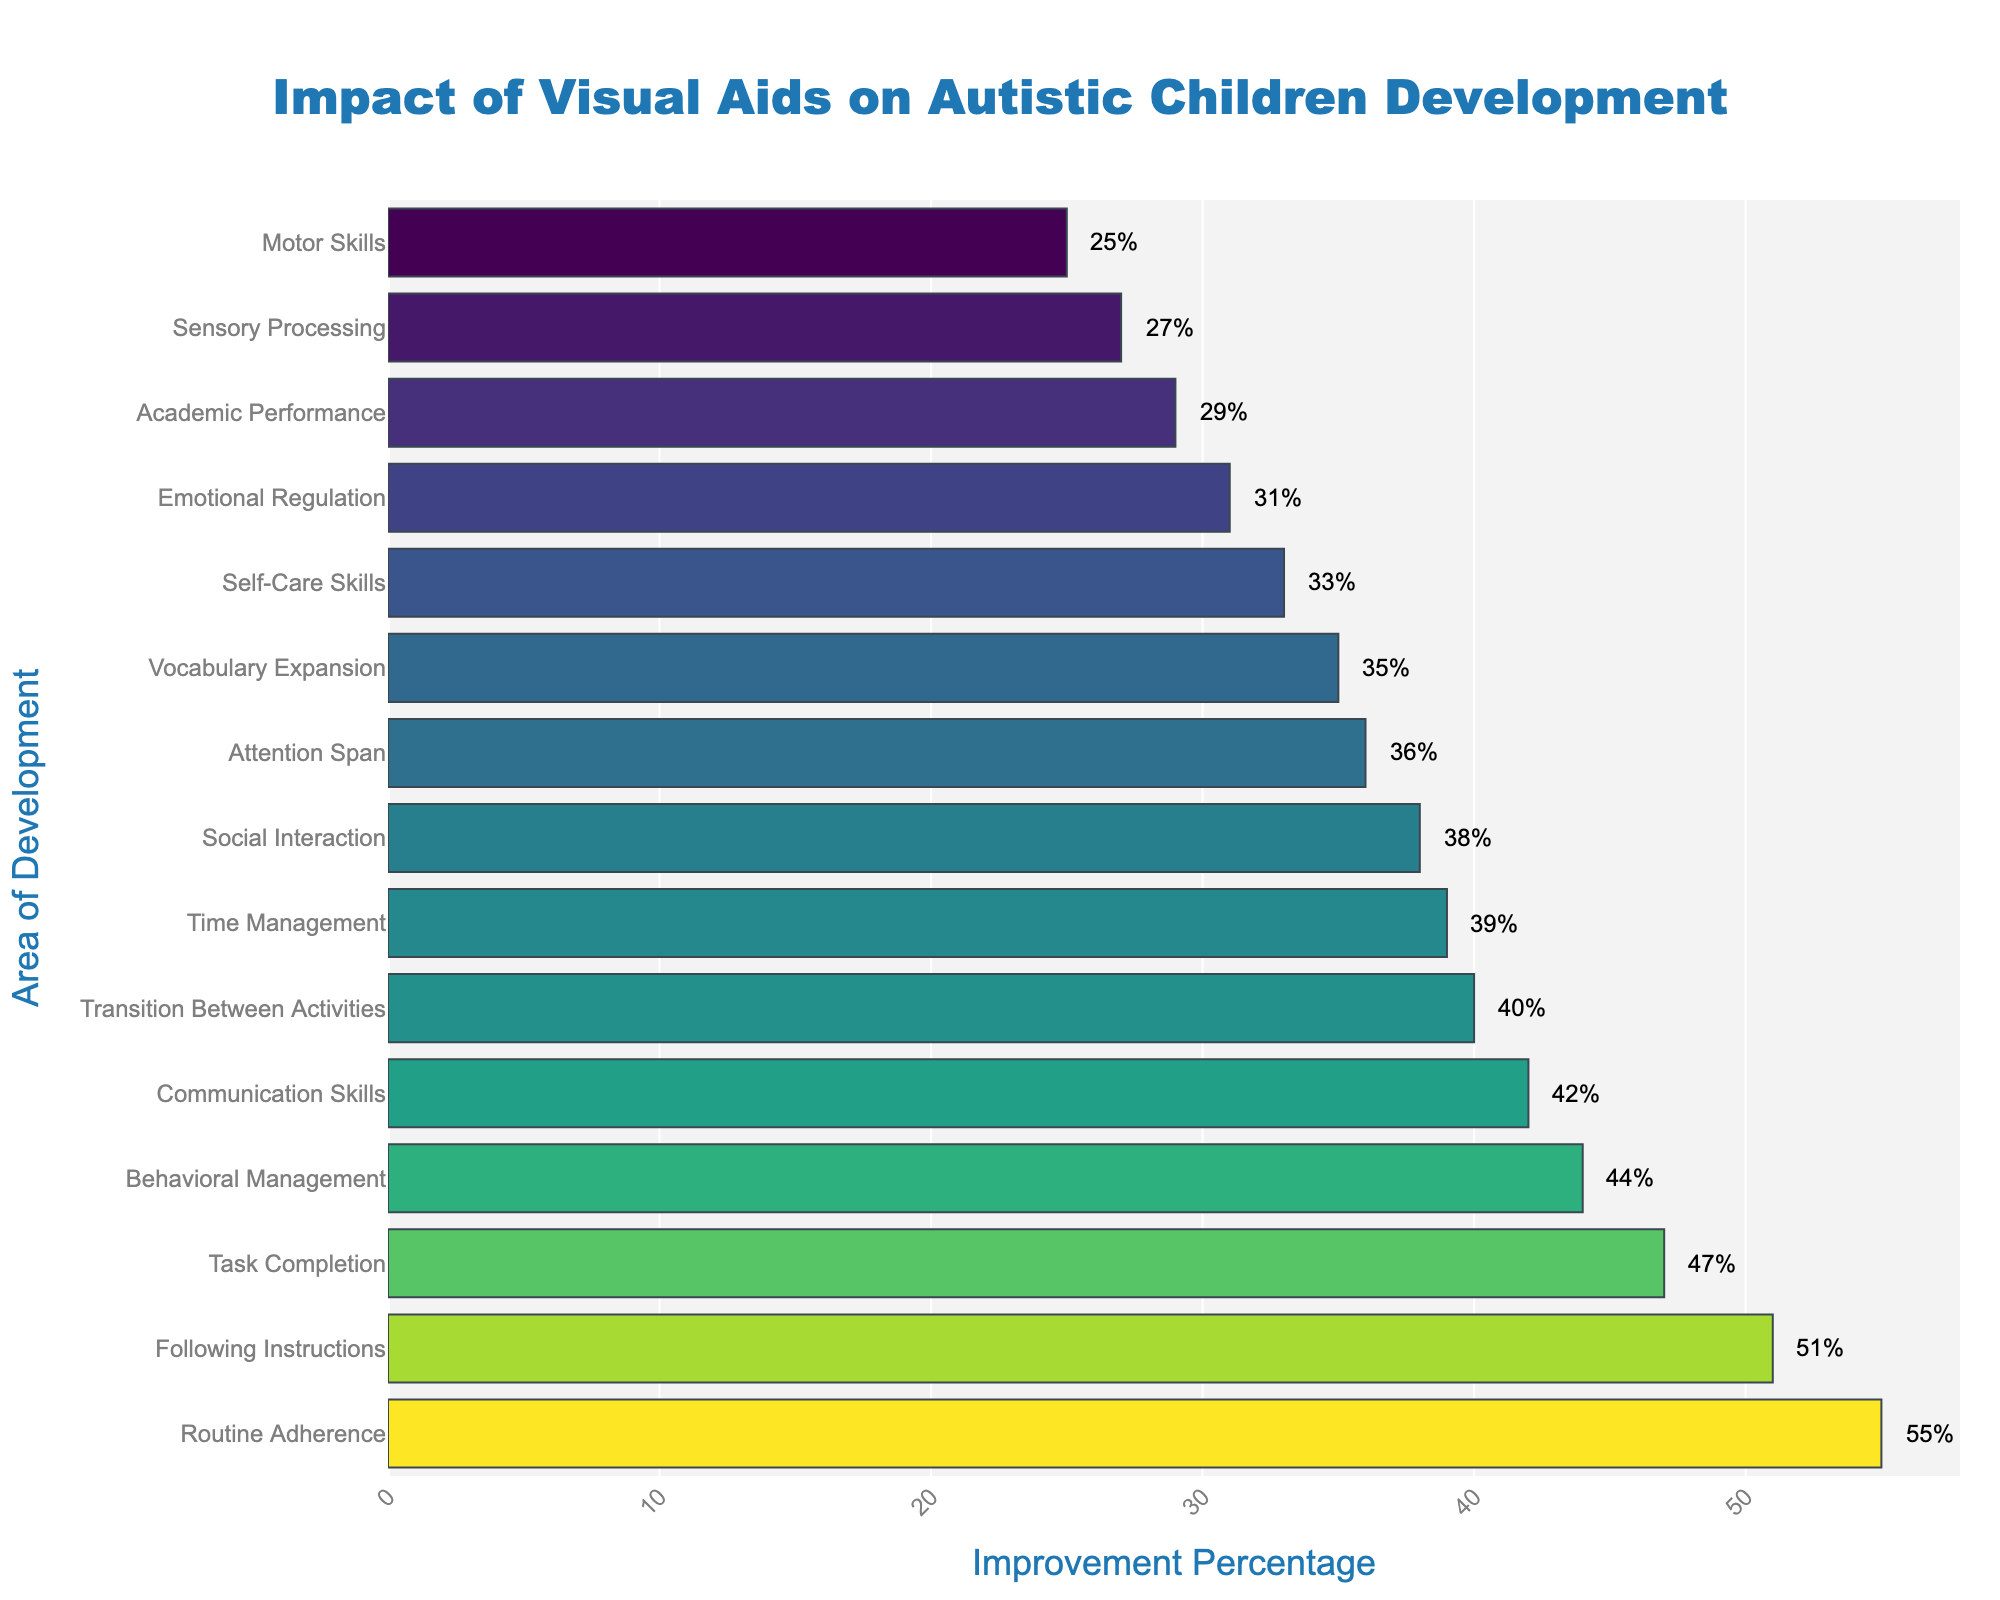What's the highest improvement percentage and which area of development does it correspond to? The highest improvement percentage is easily identifiable by looking at the longest bar in the chart, which is at the top as the data is sorted in descending order. This bar corresponds to "Routine Adherence" with an improvement percentage of 55%.
Answer: Routine Adherence, 55% Which area of development has a higher improvement in percentage: Social Interaction or Emotional Regulation? By visually comparing the bars representing "Social Interaction" and "Emotional Regulation," we see that the bar for "Social Interaction" extends further along the horizontal axis, indicating a higher percentage. Specifically, Social Interaction has an improvement of 38%, whereas Emotional Regulation has 31%.
Answer: Social Interaction What's the difference in improvement percentages between Task Completion and Self-Care Skills? Looking at the bars for "Task Completion" and "Self-Care Skills," Task Completion shows an improvement of 47% and Self-Care Skills show 33%. The difference can be calculated as 47% - 33% = 14%.
Answer: 14% Which improvement percentage is the median value in the chart? To find the median, we need to order all improvement percentages and find the middle value. With 15 data points, the median is the 8th value in the ordered list: [25, 27, 29, 31, 33, 35, 36, 38, 39, 40, 42, 44, 47, 51, 55]. The median value is 38%.
Answer: 38 Which area of development has the closest improvement percentage to 50%? By visually inspecting the chart or numerically comparing the values provided, "Following Instructions" has an improvement percentage of 51%, which is closest to 50%.
Answer: Following Instructions How many areas of development have an improvement percentage of 40 or higher? By counting the bars that extend to or past 40% on the horizontal axis, we find that there are eight areas: Routine Adherence, Following Instructions, Task Completion, Behavioral Management, Communication Skills, Transition Between Activities, Time Management, and Social Interaction.
Answer: 8 Which area of development has the lowest improvement percentage? The shortest bar on the chart corresponds to the area with the lowest improvement. This is "Motor Skills," with an improvement of 25%.
Answer: Motor Skills, 25% What is the average improvement percentage of Communication Skills, Task Completion, and Time Management? First, locate the bars and note their improvement percentages: Communication Skills (42%), Task Completion (47%), and Time Management (39%). Sum these percentages: 42 + 47 + 39 = 128. Then, divide by the number of areas (3): 128 / 3 = approximately 42.67%.
Answer: 42.67 Arrange the areas of development with improvement percentages between 30 and 40 in alphabetical order. The areas with improvement percentages between 30 and 40 are Emotional Regulation (31%), Self-Care Skills (33%), Attention Span (36%), Vocabulary Expansion (35%), and Transition Between Activities (40%). Alphabetically ordered, they are: Attention Span, Emotional Regulation, Self-Care Skills, Transition Between Activities, Vocabulary Expansion.
Answer: Attention Span, Emotional Regulation, Self-Care Skills, Transition Between Activities, Vocabulary Expansion 